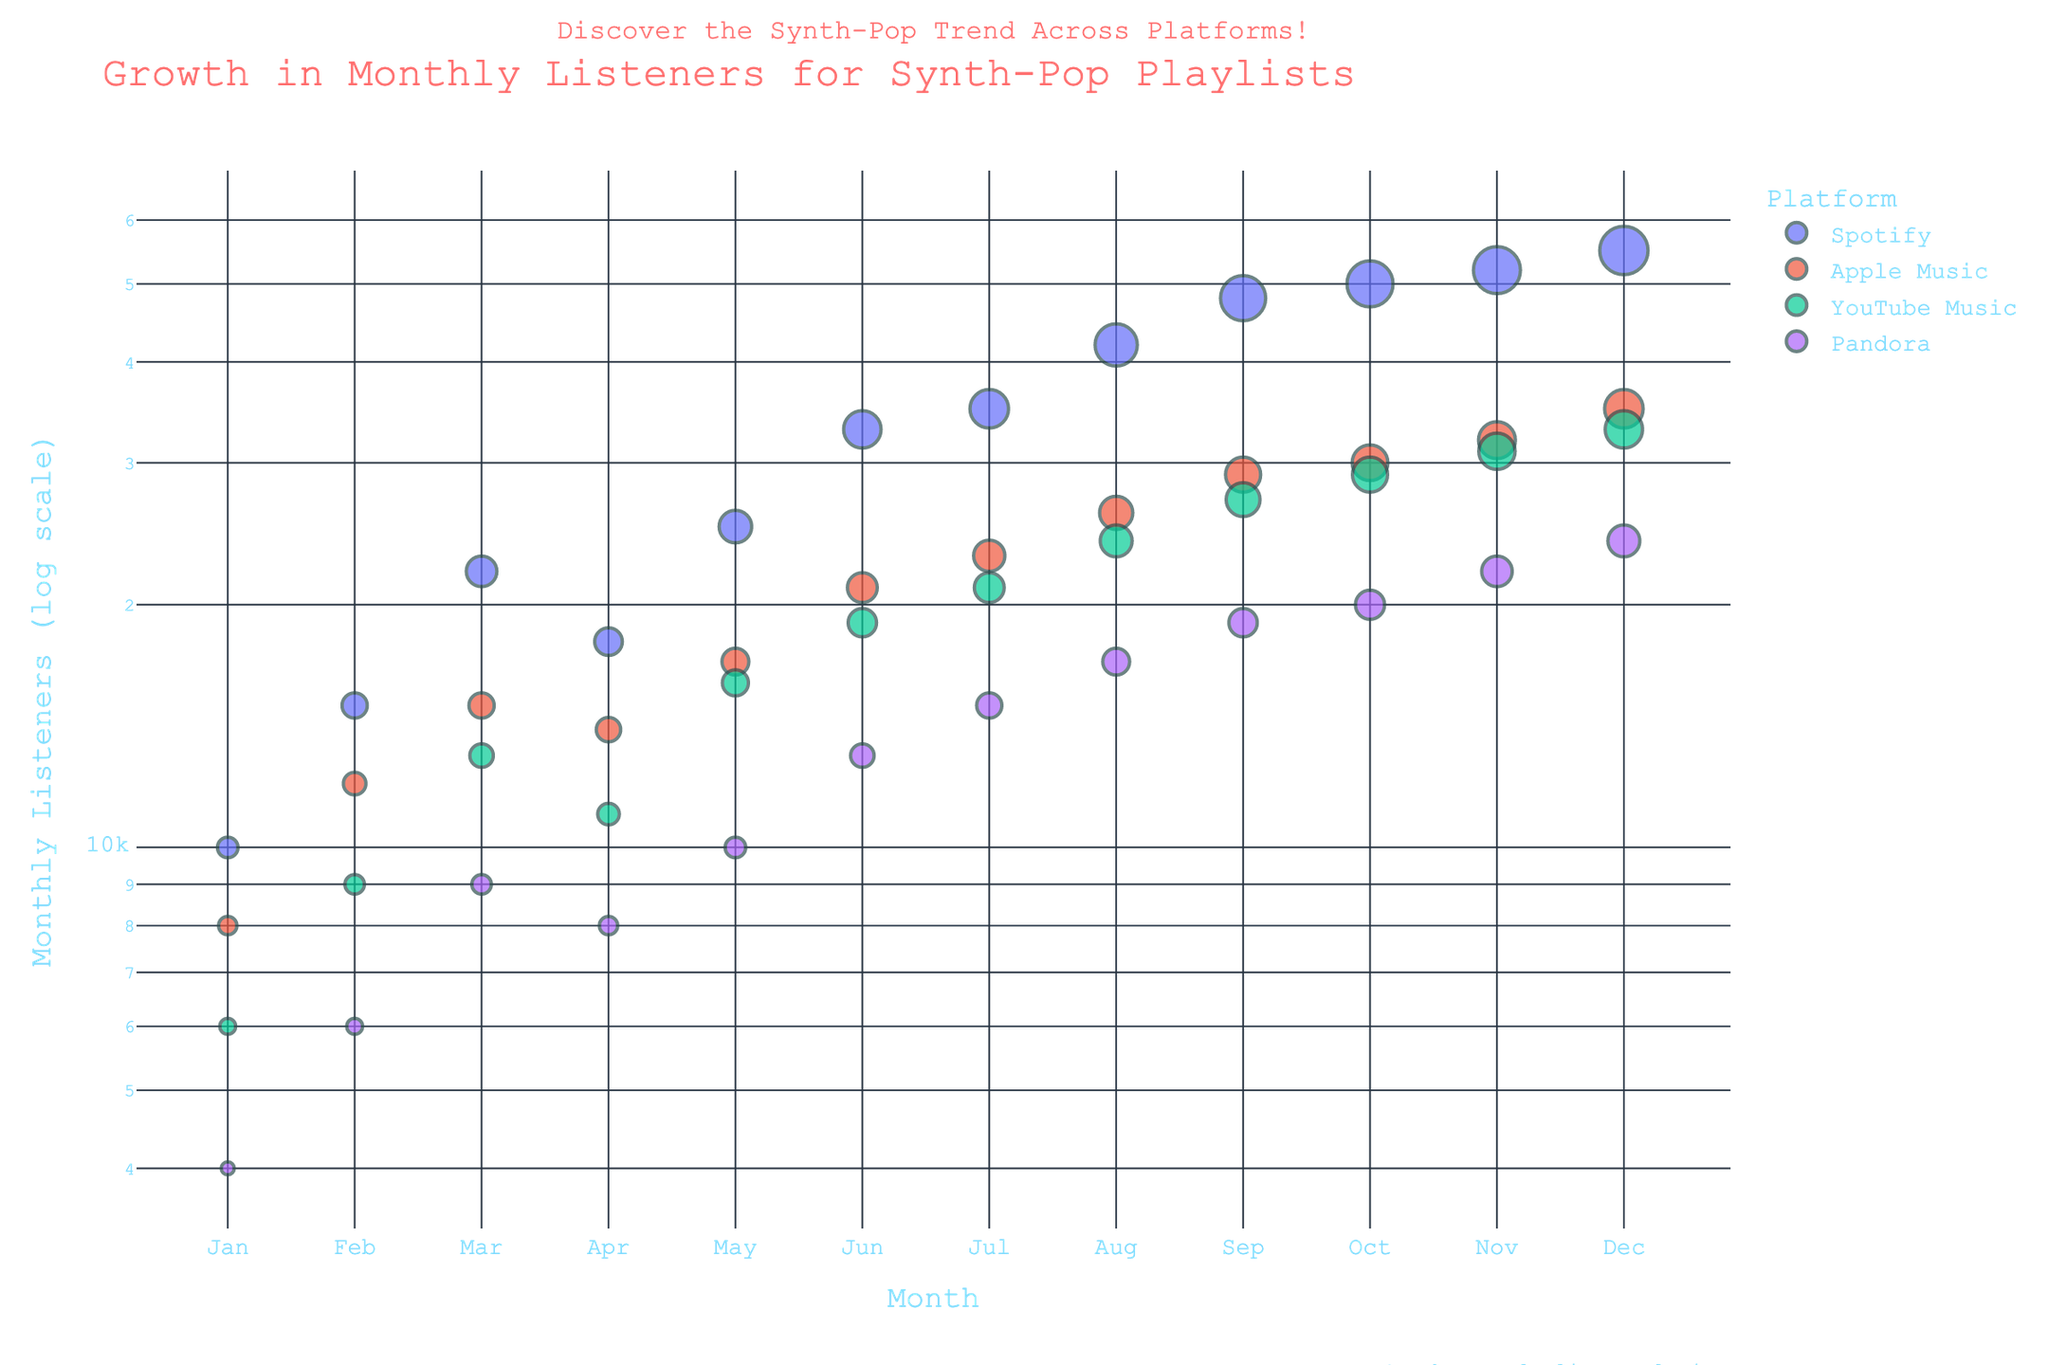what is the title of the figure? The title of the figure is displayed prominently at the top and it provides a summary of what the plot is about: "Growth in Monthly Listeners for Synth-Pop Playlists on Different Platforms".
Answer: Growth in Monthly Listeners for Synth-Pop Playlists How does the number of monthly listeners on Pandora in June compare to YouTube Music in the same month? Locate the data points for Pandora and YouTube Music in June. Pandora shows around 13,000 listeners while YouTube Music has about 19,000 listeners. Thus, YouTube Music has more monthly listeners than Pandora.
Answer: YouTube Music has more listeners Which platform saw the highest growth by the end of the year? Look at the data points for December on all platforms. Spotify reaches 55,000, while Apple Music is at 35,000, YouTube Music at 33,000, and Pandora at 24,000. Spotify shows the highest number of monthly listeners by the end of the year.
Answer: Spotify What is the overall trend for monthly listeners across all platforms? Observing the data points for each platform from January to December, there's a noticeable upward trend in monthly listeners across all platforms, indicating growth in popularity.
Answer: Upward trend On average, which platform had the smallest increase in listeners between Jan and Dec? For each platform, subtract the January value from the December value and calculate the average increase:
Spotify: 55,000 - 10,000 = 45,000
Apple Music: 35,000 - 8,000 = 27,000
YouTube Music: 33,000 - 6,000 = 27,000
Pandora: 24,000 - 4,000 = 20,000
The smallest increase is observed in Pandora.
Answer: Pandora What month showed the highest increase in listeners for Spotify? By comparing consecutive months for Spotify, the increase from May to June (33,000 - 25,000) shows the highest increase of 8,000 listeners in a single month.
Answer: June How does the distribution of monthly listeners appear for all platforms in log scale? In a log scale scatter plot, data points are more spread out, especially at the lower end of the scale. This effectively highlights differences in listener counts even at low ranges for different platforms.
Answer: More spread out, especially at low ranges 